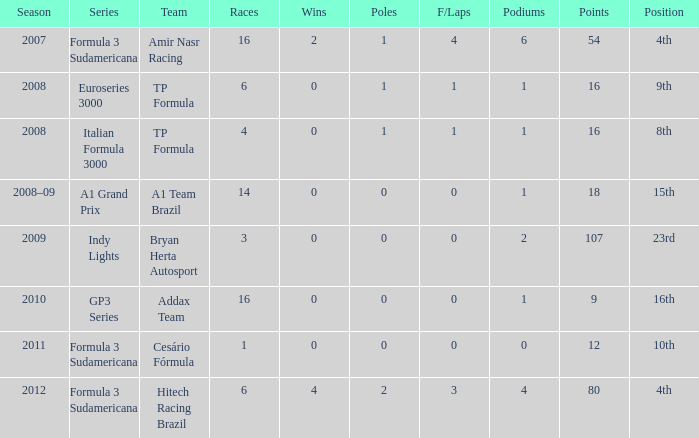What team did he compete for in the GP3 series? Addax Team. 